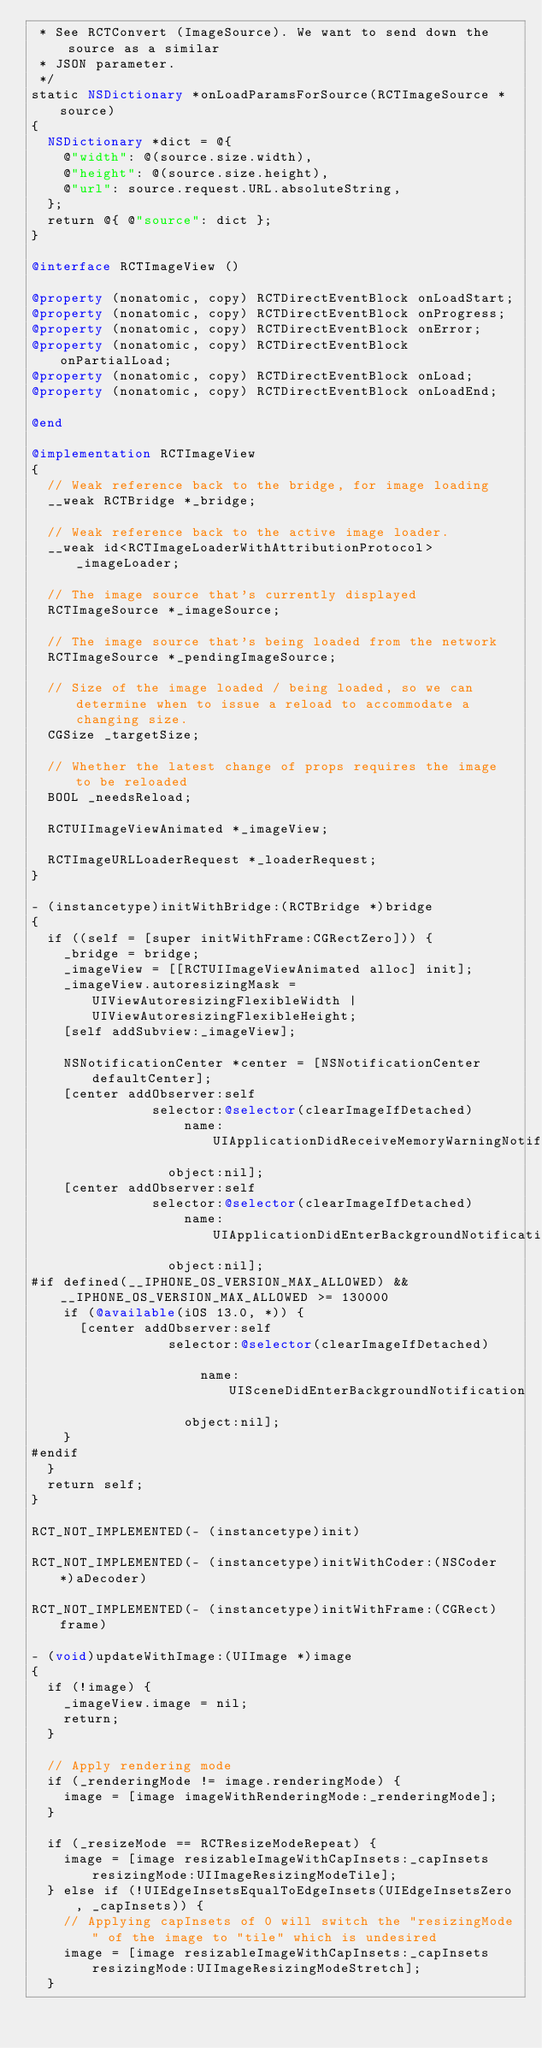<code> <loc_0><loc_0><loc_500><loc_500><_ObjectiveC_> * See RCTConvert (ImageSource). We want to send down the source as a similar
 * JSON parameter.
 */
static NSDictionary *onLoadParamsForSource(RCTImageSource *source)
{
  NSDictionary *dict = @{
    @"width": @(source.size.width),
    @"height": @(source.size.height),
    @"url": source.request.URL.absoluteString,
  };
  return @{ @"source": dict };
}

@interface RCTImageView ()

@property (nonatomic, copy) RCTDirectEventBlock onLoadStart;
@property (nonatomic, copy) RCTDirectEventBlock onProgress;
@property (nonatomic, copy) RCTDirectEventBlock onError;
@property (nonatomic, copy) RCTDirectEventBlock onPartialLoad;
@property (nonatomic, copy) RCTDirectEventBlock onLoad;
@property (nonatomic, copy) RCTDirectEventBlock onLoadEnd;

@end

@implementation RCTImageView
{
  // Weak reference back to the bridge, for image loading
  __weak RCTBridge *_bridge;

  // Weak reference back to the active image loader.
  __weak id<RCTImageLoaderWithAttributionProtocol> _imageLoader;

  // The image source that's currently displayed
  RCTImageSource *_imageSource;

  // The image source that's being loaded from the network
  RCTImageSource *_pendingImageSource;

  // Size of the image loaded / being loaded, so we can determine when to issue a reload to accommodate a changing size.
  CGSize _targetSize;

  // Whether the latest change of props requires the image to be reloaded
  BOOL _needsReload;

  RCTUIImageViewAnimated *_imageView;
  
  RCTImageURLLoaderRequest *_loaderRequest;
}

- (instancetype)initWithBridge:(RCTBridge *)bridge
{
  if ((self = [super initWithFrame:CGRectZero])) {
    _bridge = bridge;
    _imageView = [[RCTUIImageViewAnimated alloc] init];
    _imageView.autoresizingMask = UIViewAutoresizingFlexibleWidth | UIViewAutoresizingFlexibleHeight;
    [self addSubview:_imageView];

    NSNotificationCenter *center = [NSNotificationCenter defaultCenter];
    [center addObserver:self
               selector:@selector(clearImageIfDetached)
                   name:UIApplicationDidReceiveMemoryWarningNotification
                 object:nil];
    [center addObserver:self
               selector:@selector(clearImageIfDetached)
                   name:UIApplicationDidEnterBackgroundNotification
                 object:nil];
#if defined(__IPHONE_OS_VERSION_MAX_ALLOWED) && __IPHONE_OS_VERSION_MAX_ALLOWED >= 130000
    if (@available(iOS 13.0, *)) {
      [center addObserver:self
                 selector:@selector(clearImageIfDetached)

                     name:UISceneDidEnterBackgroundNotification
                   object:nil];
    }
#endif
  }
  return self;
}

RCT_NOT_IMPLEMENTED(- (instancetype)init)

RCT_NOT_IMPLEMENTED(- (instancetype)initWithCoder:(NSCoder *)aDecoder)

RCT_NOT_IMPLEMENTED(- (instancetype)initWithFrame:(CGRect)frame)

- (void)updateWithImage:(UIImage *)image
{
  if (!image) {
    _imageView.image = nil;
    return;
  }

  // Apply rendering mode
  if (_renderingMode != image.renderingMode) {
    image = [image imageWithRenderingMode:_renderingMode];
  }

  if (_resizeMode == RCTResizeModeRepeat) {
    image = [image resizableImageWithCapInsets:_capInsets resizingMode:UIImageResizingModeTile];
  } else if (!UIEdgeInsetsEqualToEdgeInsets(UIEdgeInsetsZero, _capInsets)) {
    // Applying capInsets of 0 will switch the "resizingMode" of the image to "tile" which is undesired
    image = [image resizableImageWithCapInsets:_capInsets resizingMode:UIImageResizingModeStretch];
  }
</code> 